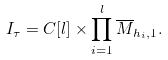Convert formula to latex. <formula><loc_0><loc_0><loc_500><loc_500>I _ { \tau } = C [ l ] \times \prod _ { i = 1 } ^ { l } \overline { M } _ { h _ { i } , 1 } .</formula> 